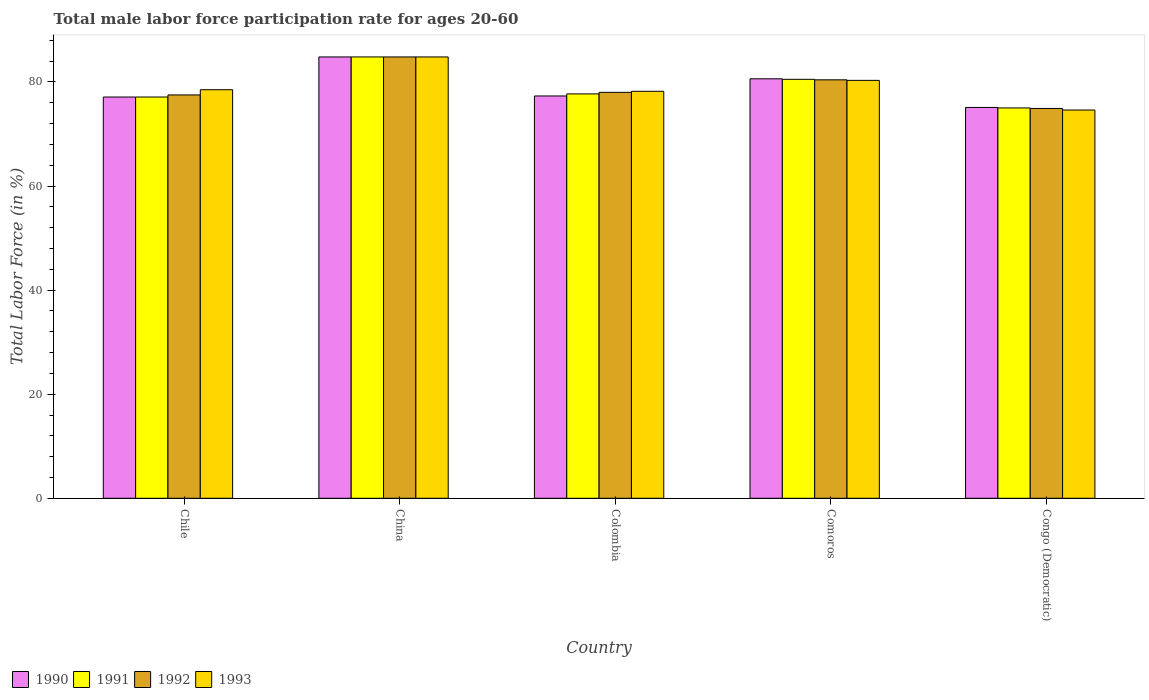How many different coloured bars are there?
Your answer should be compact. 4. How many groups of bars are there?
Provide a short and direct response. 5. Are the number of bars on each tick of the X-axis equal?
Your answer should be very brief. Yes. How many bars are there on the 5th tick from the left?
Offer a very short reply. 4. How many bars are there on the 1st tick from the right?
Your answer should be compact. 4. What is the label of the 5th group of bars from the left?
Give a very brief answer. Congo (Democratic). In how many cases, is the number of bars for a given country not equal to the number of legend labels?
Offer a terse response. 0. What is the male labor force participation rate in 1992 in Congo (Democratic)?
Your response must be concise. 74.9. Across all countries, what is the maximum male labor force participation rate in 1993?
Provide a short and direct response. 84.8. Across all countries, what is the minimum male labor force participation rate in 1991?
Make the answer very short. 75. In which country was the male labor force participation rate in 1992 minimum?
Make the answer very short. Congo (Democratic). What is the total male labor force participation rate in 1990 in the graph?
Keep it short and to the point. 394.9. What is the difference between the male labor force participation rate in 1992 in Chile and that in Comoros?
Provide a short and direct response. -2.9. What is the difference between the male labor force participation rate in 1990 in Chile and the male labor force participation rate in 1993 in Congo (Democratic)?
Give a very brief answer. 2.5. What is the average male labor force participation rate in 1993 per country?
Make the answer very short. 79.28. What is the difference between the male labor force participation rate of/in 1992 and male labor force participation rate of/in 1991 in Congo (Democratic)?
Make the answer very short. -0.1. What is the ratio of the male labor force participation rate in 1992 in Chile to that in Colombia?
Your response must be concise. 0.99. Is the male labor force participation rate in 1992 in China less than that in Comoros?
Keep it short and to the point. No. What is the difference between the highest and the second highest male labor force participation rate in 1992?
Provide a short and direct response. -4.4. What is the difference between the highest and the lowest male labor force participation rate in 1993?
Offer a very short reply. 10.2. Is it the case that in every country, the sum of the male labor force participation rate in 1990 and male labor force participation rate in 1991 is greater than the sum of male labor force participation rate in 1993 and male labor force participation rate in 1992?
Your answer should be very brief. No. What does the 2nd bar from the left in Chile represents?
Keep it short and to the point. 1991. Are all the bars in the graph horizontal?
Offer a terse response. No. What is the difference between two consecutive major ticks on the Y-axis?
Your answer should be compact. 20. Where does the legend appear in the graph?
Ensure brevity in your answer.  Bottom left. How many legend labels are there?
Provide a short and direct response. 4. How are the legend labels stacked?
Give a very brief answer. Horizontal. What is the title of the graph?
Offer a terse response. Total male labor force participation rate for ages 20-60. Does "2013" appear as one of the legend labels in the graph?
Make the answer very short. No. What is the Total Labor Force (in %) of 1990 in Chile?
Your answer should be very brief. 77.1. What is the Total Labor Force (in %) of 1991 in Chile?
Your response must be concise. 77.1. What is the Total Labor Force (in %) of 1992 in Chile?
Give a very brief answer. 77.5. What is the Total Labor Force (in %) in 1993 in Chile?
Provide a succinct answer. 78.5. What is the Total Labor Force (in %) in 1990 in China?
Offer a terse response. 84.8. What is the Total Labor Force (in %) of 1991 in China?
Provide a succinct answer. 84.8. What is the Total Labor Force (in %) of 1992 in China?
Your answer should be very brief. 84.8. What is the Total Labor Force (in %) in 1993 in China?
Your answer should be compact. 84.8. What is the Total Labor Force (in %) of 1990 in Colombia?
Provide a succinct answer. 77.3. What is the Total Labor Force (in %) of 1991 in Colombia?
Keep it short and to the point. 77.7. What is the Total Labor Force (in %) of 1993 in Colombia?
Offer a terse response. 78.2. What is the Total Labor Force (in %) of 1990 in Comoros?
Provide a succinct answer. 80.6. What is the Total Labor Force (in %) in 1991 in Comoros?
Your response must be concise. 80.5. What is the Total Labor Force (in %) in 1992 in Comoros?
Your answer should be very brief. 80.4. What is the Total Labor Force (in %) of 1993 in Comoros?
Make the answer very short. 80.3. What is the Total Labor Force (in %) of 1990 in Congo (Democratic)?
Give a very brief answer. 75.1. What is the Total Labor Force (in %) of 1991 in Congo (Democratic)?
Provide a short and direct response. 75. What is the Total Labor Force (in %) in 1992 in Congo (Democratic)?
Your response must be concise. 74.9. What is the Total Labor Force (in %) in 1993 in Congo (Democratic)?
Your answer should be compact. 74.6. Across all countries, what is the maximum Total Labor Force (in %) of 1990?
Make the answer very short. 84.8. Across all countries, what is the maximum Total Labor Force (in %) of 1991?
Offer a terse response. 84.8. Across all countries, what is the maximum Total Labor Force (in %) in 1992?
Your answer should be compact. 84.8. Across all countries, what is the maximum Total Labor Force (in %) of 1993?
Make the answer very short. 84.8. Across all countries, what is the minimum Total Labor Force (in %) of 1990?
Offer a terse response. 75.1. Across all countries, what is the minimum Total Labor Force (in %) of 1991?
Your answer should be compact. 75. Across all countries, what is the minimum Total Labor Force (in %) of 1992?
Your answer should be very brief. 74.9. Across all countries, what is the minimum Total Labor Force (in %) of 1993?
Provide a succinct answer. 74.6. What is the total Total Labor Force (in %) of 1990 in the graph?
Keep it short and to the point. 394.9. What is the total Total Labor Force (in %) in 1991 in the graph?
Ensure brevity in your answer.  395.1. What is the total Total Labor Force (in %) of 1992 in the graph?
Provide a short and direct response. 395.6. What is the total Total Labor Force (in %) of 1993 in the graph?
Offer a very short reply. 396.4. What is the difference between the Total Labor Force (in %) of 1990 in Chile and that in China?
Provide a short and direct response. -7.7. What is the difference between the Total Labor Force (in %) of 1992 in Chile and that in China?
Offer a terse response. -7.3. What is the difference between the Total Labor Force (in %) in 1993 in Chile and that in China?
Give a very brief answer. -6.3. What is the difference between the Total Labor Force (in %) of 1992 in Chile and that in Colombia?
Provide a succinct answer. -0.5. What is the difference between the Total Labor Force (in %) in 1993 in Chile and that in Colombia?
Your answer should be compact. 0.3. What is the difference between the Total Labor Force (in %) of 1990 in Chile and that in Comoros?
Your answer should be compact. -3.5. What is the difference between the Total Labor Force (in %) in 1991 in Chile and that in Comoros?
Your response must be concise. -3.4. What is the difference between the Total Labor Force (in %) in 1992 in Chile and that in Comoros?
Keep it short and to the point. -2.9. What is the difference between the Total Labor Force (in %) in 1993 in Chile and that in Comoros?
Provide a short and direct response. -1.8. What is the difference between the Total Labor Force (in %) of 1990 in Chile and that in Congo (Democratic)?
Make the answer very short. 2. What is the difference between the Total Labor Force (in %) in 1992 in Chile and that in Congo (Democratic)?
Give a very brief answer. 2.6. What is the difference between the Total Labor Force (in %) in 1993 in Chile and that in Congo (Democratic)?
Your response must be concise. 3.9. What is the difference between the Total Labor Force (in %) in 1990 in China and that in Colombia?
Your answer should be compact. 7.5. What is the difference between the Total Labor Force (in %) in 1991 in China and that in Colombia?
Make the answer very short. 7.1. What is the difference between the Total Labor Force (in %) of 1992 in China and that in Colombia?
Provide a short and direct response. 6.8. What is the difference between the Total Labor Force (in %) in 1990 in China and that in Comoros?
Make the answer very short. 4.2. What is the difference between the Total Labor Force (in %) in 1991 in China and that in Comoros?
Ensure brevity in your answer.  4.3. What is the difference between the Total Labor Force (in %) of 1992 in China and that in Comoros?
Ensure brevity in your answer.  4.4. What is the difference between the Total Labor Force (in %) in 1993 in China and that in Comoros?
Your answer should be very brief. 4.5. What is the difference between the Total Labor Force (in %) of 1990 in China and that in Congo (Democratic)?
Ensure brevity in your answer.  9.7. What is the difference between the Total Labor Force (in %) of 1993 in China and that in Congo (Democratic)?
Offer a very short reply. 10.2. What is the difference between the Total Labor Force (in %) in 1990 in Colombia and that in Comoros?
Make the answer very short. -3.3. What is the difference between the Total Labor Force (in %) of 1992 in Colombia and that in Comoros?
Offer a very short reply. -2.4. What is the difference between the Total Labor Force (in %) in 1990 in Colombia and that in Congo (Democratic)?
Give a very brief answer. 2.2. What is the difference between the Total Labor Force (in %) of 1992 in Colombia and that in Congo (Democratic)?
Provide a succinct answer. 3.1. What is the difference between the Total Labor Force (in %) in 1990 in Comoros and that in Congo (Democratic)?
Offer a terse response. 5.5. What is the difference between the Total Labor Force (in %) of 1993 in Comoros and that in Congo (Democratic)?
Keep it short and to the point. 5.7. What is the difference between the Total Labor Force (in %) of 1990 in Chile and the Total Labor Force (in %) of 1991 in China?
Your answer should be very brief. -7.7. What is the difference between the Total Labor Force (in %) of 1990 in Chile and the Total Labor Force (in %) of 1992 in China?
Provide a short and direct response. -7.7. What is the difference between the Total Labor Force (in %) of 1991 in Chile and the Total Labor Force (in %) of 1993 in China?
Offer a terse response. -7.7. What is the difference between the Total Labor Force (in %) of 1992 in Chile and the Total Labor Force (in %) of 1993 in China?
Ensure brevity in your answer.  -7.3. What is the difference between the Total Labor Force (in %) in 1990 in Chile and the Total Labor Force (in %) in 1991 in Colombia?
Provide a succinct answer. -0.6. What is the difference between the Total Labor Force (in %) of 1990 in Chile and the Total Labor Force (in %) of 1992 in Colombia?
Your answer should be compact. -0.9. What is the difference between the Total Labor Force (in %) in 1990 in Chile and the Total Labor Force (in %) in 1993 in Colombia?
Your response must be concise. -1.1. What is the difference between the Total Labor Force (in %) of 1991 in Chile and the Total Labor Force (in %) of 1993 in Colombia?
Give a very brief answer. -1.1. What is the difference between the Total Labor Force (in %) in 1990 in Chile and the Total Labor Force (in %) in 1991 in Comoros?
Give a very brief answer. -3.4. What is the difference between the Total Labor Force (in %) of 1990 in Chile and the Total Labor Force (in %) of 1992 in Comoros?
Your answer should be very brief. -3.3. What is the difference between the Total Labor Force (in %) of 1990 in Chile and the Total Labor Force (in %) of 1993 in Comoros?
Provide a short and direct response. -3.2. What is the difference between the Total Labor Force (in %) of 1991 in Chile and the Total Labor Force (in %) of 1992 in Comoros?
Provide a short and direct response. -3.3. What is the difference between the Total Labor Force (in %) in 1991 in Chile and the Total Labor Force (in %) in 1993 in Comoros?
Offer a terse response. -3.2. What is the difference between the Total Labor Force (in %) in 1992 in Chile and the Total Labor Force (in %) in 1993 in Comoros?
Offer a terse response. -2.8. What is the difference between the Total Labor Force (in %) in 1990 in Chile and the Total Labor Force (in %) in 1992 in Congo (Democratic)?
Your answer should be compact. 2.2. What is the difference between the Total Labor Force (in %) of 1991 in Chile and the Total Labor Force (in %) of 1992 in Congo (Democratic)?
Provide a short and direct response. 2.2. What is the difference between the Total Labor Force (in %) of 1992 in Chile and the Total Labor Force (in %) of 1993 in Congo (Democratic)?
Offer a very short reply. 2.9. What is the difference between the Total Labor Force (in %) in 1991 in China and the Total Labor Force (in %) in 1992 in Colombia?
Your answer should be compact. 6.8. What is the difference between the Total Labor Force (in %) in 1991 in China and the Total Labor Force (in %) in 1993 in Colombia?
Offer a very short reply. 6.6. What is the difference between the Total Labor Force (in %) in 1990 in China and the Total Labor Force (in %) in 1993 in Comoros?
Your answer should be very brief. 4.5. What is the difference between the Total Labor Force (in %) in 1991 in China and the Total Labor Force (in %) in 1992 in Comoros?
Provide a short and direct response. 4.4. What is the difference between the Total Labor Force (in %) in 1991 in China and the Total Labor Force (in %) in 1993 in Comoros?
Provide a short and direct response. 4.5. What is the difference between the Total Labor Force (in %) in 1992 in China and the Total Labor Force (in %) in 1993 in Comoros?
Your answer should be compact. 4.5. What is the difference between the Total Labor Force (in %) in 1991 in China and the Total Labor Force (in %) in 1992 in Congo (Democratic)?
Offer a terse response. 9.9. What is the difference between the Total Labor Force (in %) of 1992 in China and the Total Labor Force (in %) of 1993 in Congo (Democratic)?
Ensure brevity in your answer.  10.2. What is the difference between the Total Labor Force (in %) of 1990 in Colombia and the Total Labor Force (in %) of 1992 in Comoros?
Your answer should be compact. -3.1. What is the difference between the Total Labor Force (in %) of 1990 in Colombia and the Total Labor Force (in %) of 1993 in Comoros?
Offer a terse response. -3. What is the difference between the Total Labor Force (in %) in 1992 in Colombia and the Total Labor Force (in %) in 1993 in Comoros?
Your response must be concise. -2.3. What is the difference between the Total Labor Force (in %) in 1992 in Colombia and the Total Labor Force (in %) in 1993 in Congo (Democratic)?
Offer a very short reply. 3.4. What is the difference between the Total Labor Force (in %) in 1990 in Comoros and the Total Labor Force (in %) in 1991 in Congo (Democratic)?
Your answer should be very brief. 5.6. What is the difference between the Total Labor Force (in %) in 1990 in Comoros and the Total Labor Force (in %) in 1992 in Congo (Democratic)?
Make the answer very short. 5.7. What is the difference between the Total Labor Force (in %) of 1991 in Comoros and the Total Labor Force (in %) of 1992 in Congo (Democratic)?
Your answer should be very brief. 5.6. What is the average Total Labor Force (in %) of 1990 per country?
Ensure brevity in your answer.  78.98. What is the average Total Labor Force (in %) of 1991 per country?
Give a very brief answer. 79.02. What is the average Total Labor Force (in %) of 1992 per country?
Offer a very short reply. 79.12. What is the average Total Labor Force (in %) in 1993 per country?
Offer a terse response. 79.28. What is the difference between the Total Labor Force (in %) of 1990 and Total Labor Force (in %) of 1993 in Chile?
Give a very brief answer. -1.4. What is the difference between the Total Labor Force (in %) in 1991 and Total Labor Force (in %) in 1993 in Chile?
Your response must be concise. -1.4. What is the difference between the Total Labor Force (in %) in 1992 and Total Labor Force (in %) in 1993 in Chile?
Your answer should be compact. -1. What is the difference between the Total Labor Force (in %) of 1990 and Total Labor Force (in %) of 1991 in China?
Offer a very short reply. 0. What is the difference between the Total Labor Force (in %) of 1990 and Total Labor Force (in %) of 1992 in China?
Ensure brevity in your answer.  0. What is the difference between the Total Labor Force (in %) of 1991 and Total Labor Force (in %) of 1992 in China?
Give a very brief answer. 0. What is the difference between the Total Labor Force (in %) of 1991 and Total Labor Force (in %) of 1993 in China?
Provide a short and direct response. 0. What is the difference between the Total Labor Force (in %) of 1990 and Total Labor Force (in %) of 1993 in Colombia?
Give a very brief answer. -0.9. What is the difference between the Total Labor Force (in %) of 1991 and Total Labor Force (in %) of 1992 in Colombia?
Give a very brief answer. -0.3. What is the difference between the Total Labor Force (in %) in 1991 and Total Labor Force (in %) in 1993 in Colombia?
Provide a short and direct response. -0.5. What is the difference between the Total Labor Force (in %) in 1990 and Total Labor Force (in %) in 1992 in Comoros?
Your answer should be compact. 0.2. What is the difference between the Total Labor Force (in %) of 1990 and Total Labor Force (in %) of 1993 in Comoros?
Your answer should be compact. 0.3. What is the difference between the Total Labor Force (in %) in 1991 and Total Labor Force (in %) in 1993 in Comoros?
Offer a very short reply. 0.2. What is the difference between the Total Labor Force (in %) of 1992 and Total Labor Force (in %) of 1993 in Comoros?
Your answer should be very brief. 0.1. What is the difference between the Total Labor Force (in %) of 1990 and Total Labor Force (in %) of 1991 in Congo (Democratic)?
Give a very brief answer. 0.1. What is the difference between the Total Labor Force (in %) of 1990 and Total Labor Force (in %) of 1993 in Congo (Democratic)?
Give a very brief answer. 0.5. What is the difference between the Total Labor Force (in %) in 1992 and Total Labor Force (in %) in 1993 in Congo (Democratic)?
Keep it short and to the point. 0.3. What is the ratio of the Total Labor Force (in %) of 1990 in Chile to that in China?
Provide a succinct answer. 0.91. What is the ratio of the Total Labor Force (in %) in 1991 in Chile to that in China?
Your response must be concise. 0.91. What is the ratio of the Total Labor Force (in %) of 1992 in Chile to that in China?
Make the answer very short. 0.91. What is the ratio of the Total Labor Force (in %) of 1993 in Chile to that in China?
Your response must be concise. 0.93. What is the ratio of the Total Labor Force (in %) of 1991 in Chile to that in Colombia?
Ensure brevity in your answer.  0.99. What is the ratio of the Total Labor Force (in %) in 1992 in Chile to that in Colombia?
Make the answer very short. 0.99. What is the ratio of the Total Labor Force (in %) in 1993 in Chile to that in Colombia?
Provide a short and direct response. 1. What is the ratio of the Total Labor Force (in %) in 1990 in Chile to that in Comoros?
Ensure brevity in your answer.  0.96. What is the ratio of the Total Labor Force (in %) of 1991 in Chile to that in Comoros?
Give a very brief answer. 0.96. What is the ratio of the Total Labor Force (in %) in 1992 in Chile to that in Comoros?
Provide a short and direct response. 0.96. What is the ratio of the Total Labor Force (in %) in 1993 in Chile to that in Comoros?
Offer a terse response. 0.98. What is the ratio of the Total Labor Force (in %) in 1990 in Chile to that in Congo (Democratic)?
Give a very brief answer. 1.03. What is the ratio of the Total Labor Force (in %) of 1991 in Chile to that in Congo (Democratic)?
Your response must be concise. 1.03. What is the ratio of the Total Labor Force (in %) in 1992 in Chile to that in Congo (Democratic)?
Your answer should be compact. 1.03. What is the ratio of the Total Labor Force (in %) of 1993 in Chile to that in Congo (Democratic)?
Your response must be concise. 1.05. What is the ratio of the Total Labor Force (in %) of 1990 in China to that in Colombia?
Keep it short and to the point. 1.1. What is the ratio of the Total Labor Force (in %) of 1991 in China to that in Colombia?
Provide a succinct answer. 1.09. What is the ratio of the Total Labor Force (in %) in 1992 in China to that in Colombia?
Offer a terse response. 1.09. What is the ratio of the Total Labor Force (in %) of 1993 in China to that in Colombia?
Keep it short and to the point. 1.08. What is the ratio of the Total Labor Force (in %) in 1990 in China to that in Comoros?
Make the answer very short. 1.05. What is the ratio of the Total Labor Force (in %) of 1991 in China to that in Comoros?
Your response must be concise. 1.05. What is the ratio of the Total Labor Force (in %) of 1992 in China to that in Comoros?
Provide a succinct answer. 1.05. What is the ratio of the Total Labor Force (in %) in 1993 in China to that in Comoros?
Ensure brevity in your answer.  1.06. What is the ratio of the Total Labor Force (in %) of 1990 in China to that in Congo (Democratic)?
Your answer should be compact. 1.13. What is the ratio of the Total Labor Force (in %) of 1991 in China to that in Congo (Democratic)?
Your answer should be very brief. 1.13. What is the ratio of the Total Labor Force (in %) in 1992 in China to that in Congo (Democratic)?
Make the answer very short. 1.13. What is the ratio of the Total Labor Force (in %) of 1993 in China to that in Congo (Democratic)?
Provide a short and direct response. 1.14. What is the ratio of the Total Labor Force (in %) in 1990 in Colombia to that in Comoros?
Keep it short and to the point. 0.96. What is the ratio of the Total Labor Force (in %) of 1991 in Colombia to that in Comoros?
Provide a short and direct response. 0.97. What is the ratio of the Total Labor Force (in %) of 1992 in Colombia to that in Comoros?
Your response must be concise. 0.97. What is the ratio of the Total Labor Force (in %) of 1993 in Colombia to that in Comoros?
Your response must be concise. 0.97. What is the ratio of the Total Labor Force (in %) of 1990 in Colombia to that in Congo (Democratic)?
Provide a succinct answer. 1.03. What is the ratio of the Total Labor Force (in %) of 1991 in Colombia to that in Congo (Democratic)?
Your response must be concise. 1.04. What is the ratio of the Total Labor Force (in %) in 1992 in Colombia to that in Congo (Democratic)?
Give a very brief answer. 1.04. What is the ratio of the Total Labor Force (in %) of 1993 in Colombia to that in Congo (Democratic)?
Your answer should be compact. 1.05. What is the ratio of the Total Labor Force (in %) of 1990 in Comoros to that in Congo (Democratic)?
Provide a short and direct response. 1.07. What is the ratio of the Total Labor Force (in %) of 1991 in Comoros to that in Congo (Democratic)?
Offer a terse response. 1.07. What is the ratio of the Total Labor Force (in %) of 1992 in Comoros to that in Congo (Democratic)?
Keep it short and to the point. 1.07. What is the ratio of the Total Labor Force (in %) of 1993 in Comoros to that in Congo (Democratic)?
Offer a very short reply. 1.08. What is the difference between the highest and the second highest Total Labor Force (in %) in 1992?
Offer a very short reply. 4.4. What is the difference between the highest and the lowest Total Labor Force (in %) in 1993?
Provide a succinct answer. 10.2. 